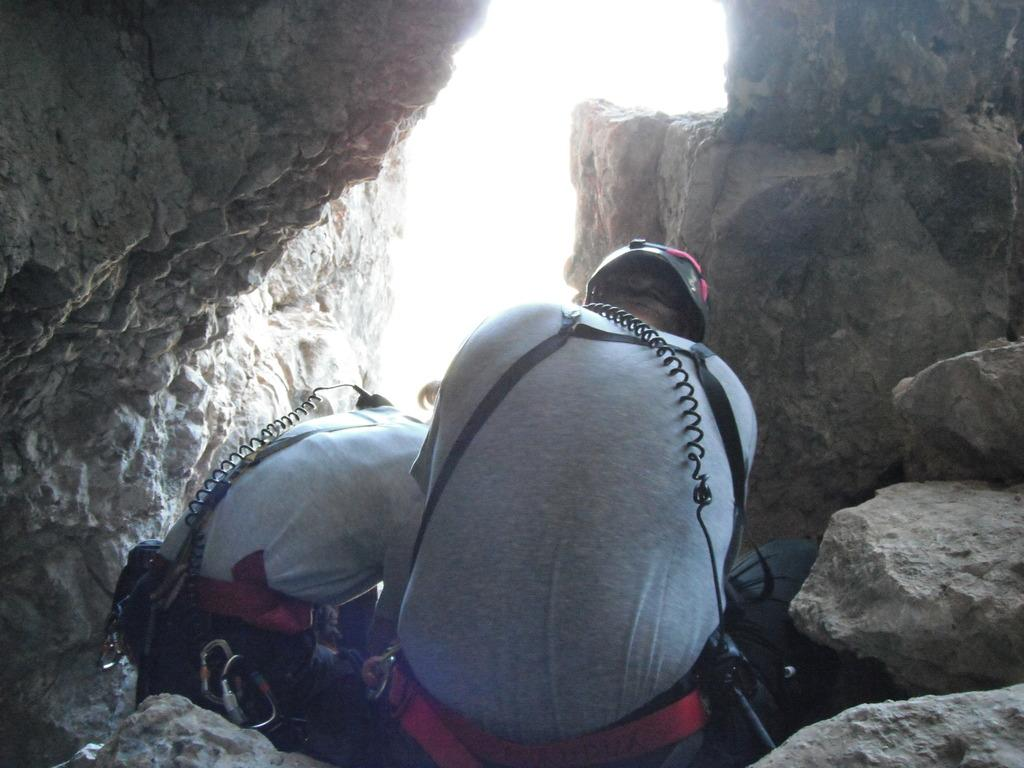How many people are in the image? There are two persons in the image. What are the persons wearing on their heads? The persons are wearing helmets. Can you describe any objects that are bending in the image? Yes, there are some objects bending in the image. What type of terrain surrounds the persons? There are rocks around the persons. What type of dress is the person on the left wearing in the image? There is no dress visible in the image, as both persons are wearing helmets. How do the persons say good-bye to each other in the image? There is no indication of the persons saying good-bye in the image. 